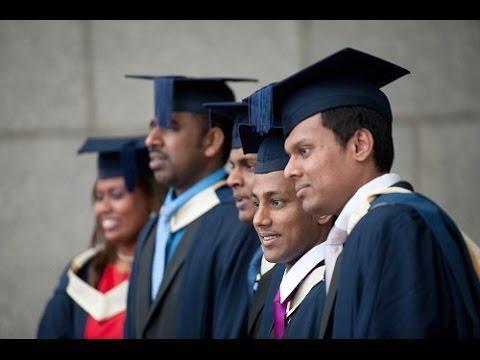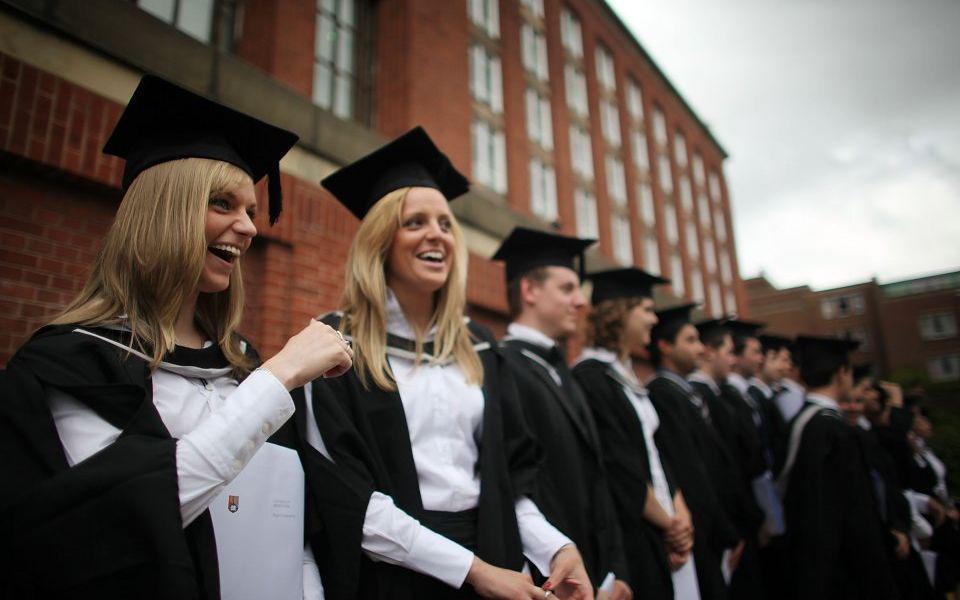The first image is the image on the left, the second image is the image on the right. For the images displayed, is the sentence "The graduates in the right image are wearing blue gowns." factually correct? Answer yes or no. No. 